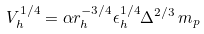Convert formula to latex. <formula><loc_0><loc_0><loc_500><loc_500>V _ { h } ^ { 1 / 4 } = \alpha r _ { h } ^ { - 3 / 4 } \epsilon _ { h } ^ { 1 / 4 } \Delta ^ { 2 / 3 } \, m _ { p }</formula> 